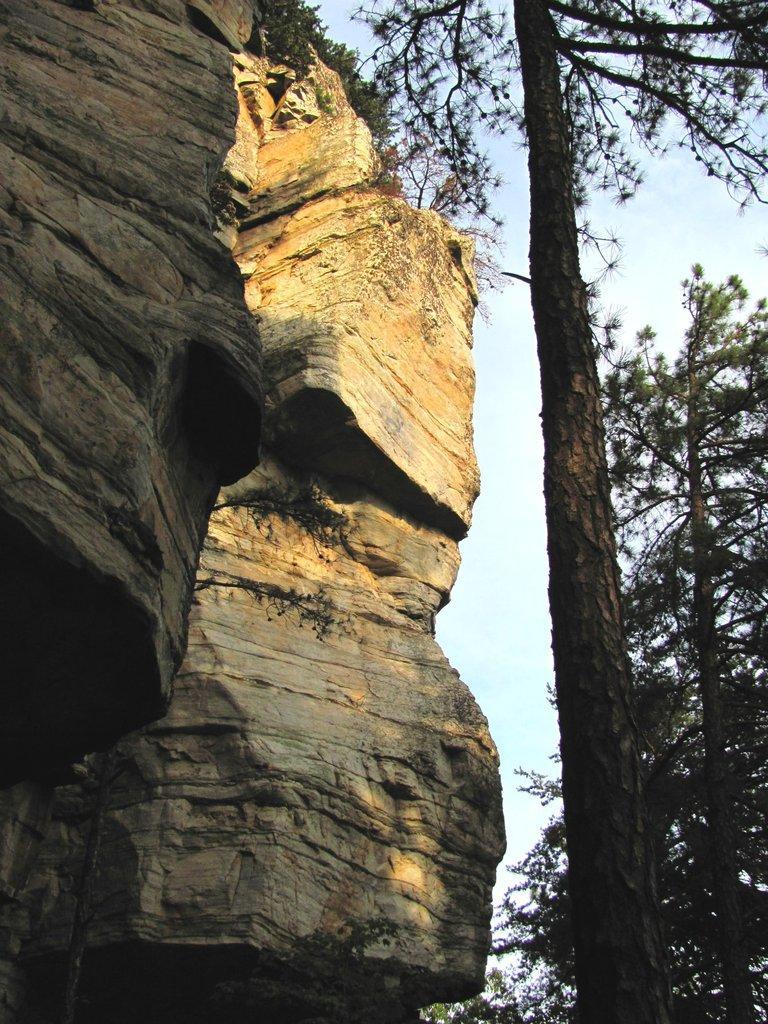Could you give a brief overview of what you see in this image? In this image, we can see rocks, trees and there is a sky at the top. 